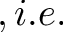<formula> <loc_0><loc_0><loc_500><loc_500>, i . e .</formula> 